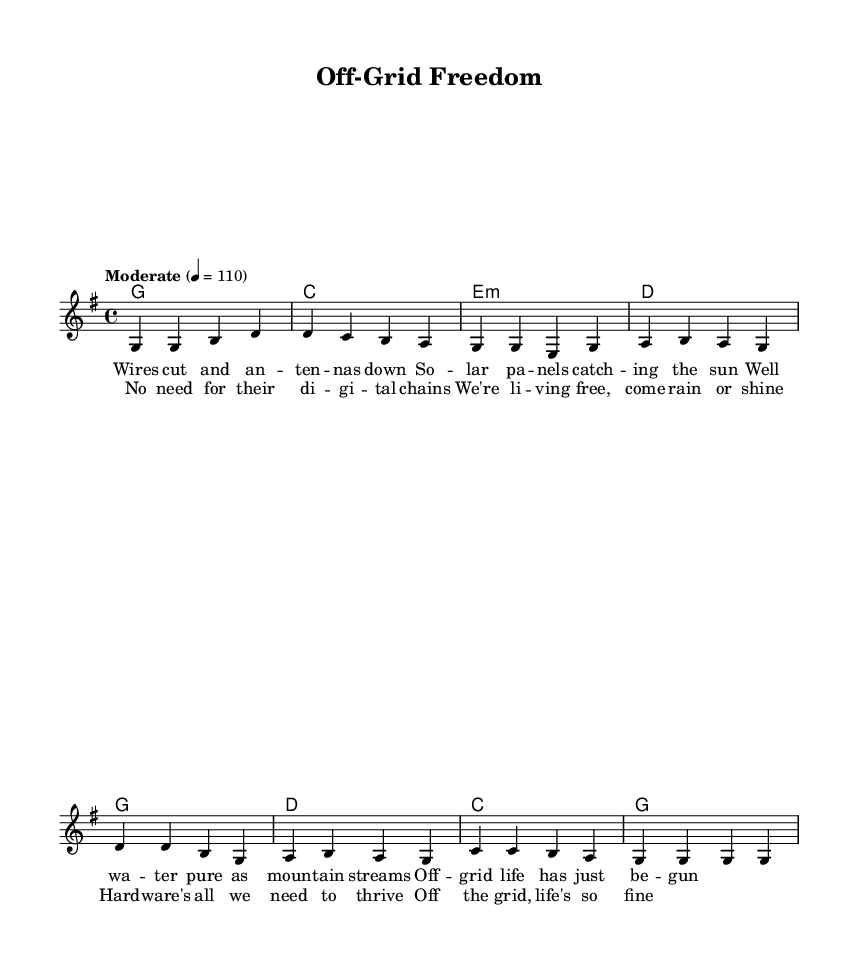What is the key signature of this music? The key signature is indicated at the beginning of the staff. In this case, it is G major, which has one sharp (F#).
Answer: G major What is the time signature of this piece? The time signature is found at the start of the music, defined as four beats per measure with the note value being a quarter note. Thus, it is represented as 4/4.
Answer: 4/4 What is the tempo marking for the piece? The tempo marking is specified in the score, showing the speed of the music which is set to moderate at 110 beats per minute.
Answer: Moderate 110 How many measures are in the verse? By counting the measures in the verse section, which consists of the corresponding melody and harmonies, we find there are four measures in the verse.
Answer: 4 Which type of harmony is used in the verse section? Looking at the chord progression provided under harmonies, we see that the chords are major and minor, specifically G, C, E minor, and D. Hence it primarily features major and minor chords.
Answer: Major and minor What is the theme of the song based on the lyrics? Analyzing the lyrics presented with the music, it focuses on the concept of independence and freedom associated with off-grid living, emphasizing self-reliance and simplicity.
Answer: Independence and freedom What is the relationship between the verse and the chorus? The verse provides the narrative of off-grid living, while the chorus reinforces the key message of living freely without digital constraints. They complement each other by contrasting detailed storytelling with a broader thematic celebration.
Answer: Complementary contrast 